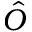<formula> <loc_0><loc_0><loc_500><loc_500>\hat { O }</formula> 